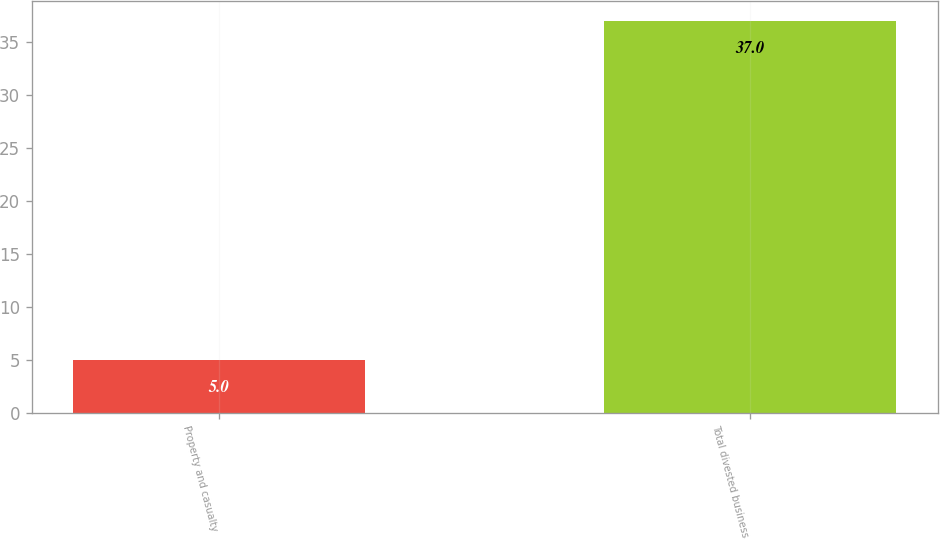Convert chart. <chart><loc_0><loc_0><loc_500><loc_500><bar_chart><fcel>Property and casualty<fcel>Total divested business<nl><fcel>5<fcel>37<nl></chart> 